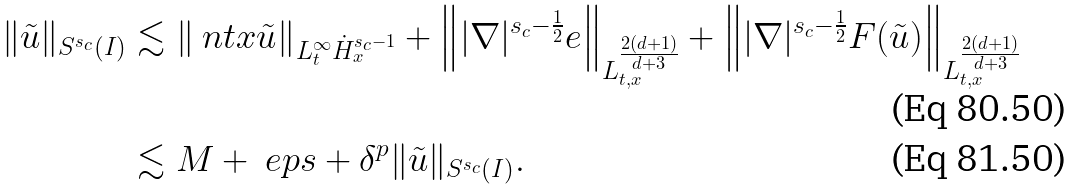<formula> <loc_0><loc_0><loc_500><loc_500>\| \tilde { u } \| _ { S ^ { s _ { c } } ( I ) } & \lesssim \left \| \ n t x \tilde { u } \right \| _ { L _ { t } ^ { \infty } \dot { H } _ { x } ^ { s _ { c } - 1 } } + \left \| | \nabla | ^ { s _ { c } - \frac { 1 } { 2 } } e \right \| _ { L _ { t , x } ^ { \frac { 2 ( d + 1 ) } { d + 3 } } } + \left \| | \nabla | ^ { s _ { c } - \frac { 1 } { 2 } } F ( \tilde { u } ) \right \| _ { L _ { t , x } ^ { \frac { 2 ( d + 1 ) } { d + 3 } } } \\ & \lesssim M + \ e p s + \delta ^ { p } \| \tilde { u } \| _ { S ^ { s _ { c } } ( I ) } .</formula> 